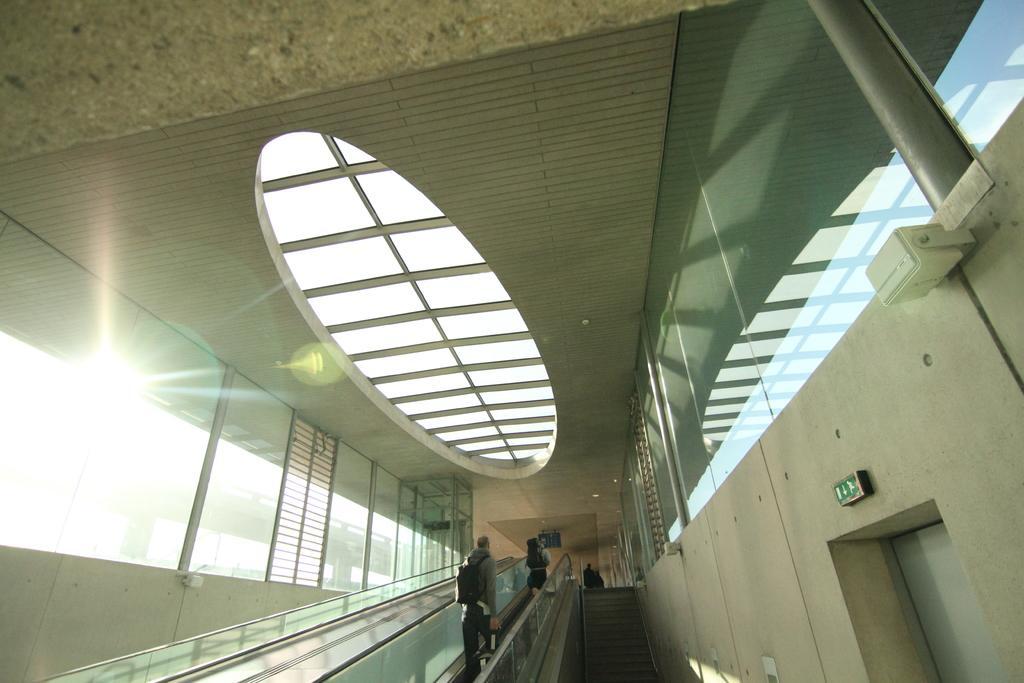How would you summarize this image in a sentence or two? In this picture we can observe two members on the escalator. We can observe glass windows. On the left side there is a sun. 